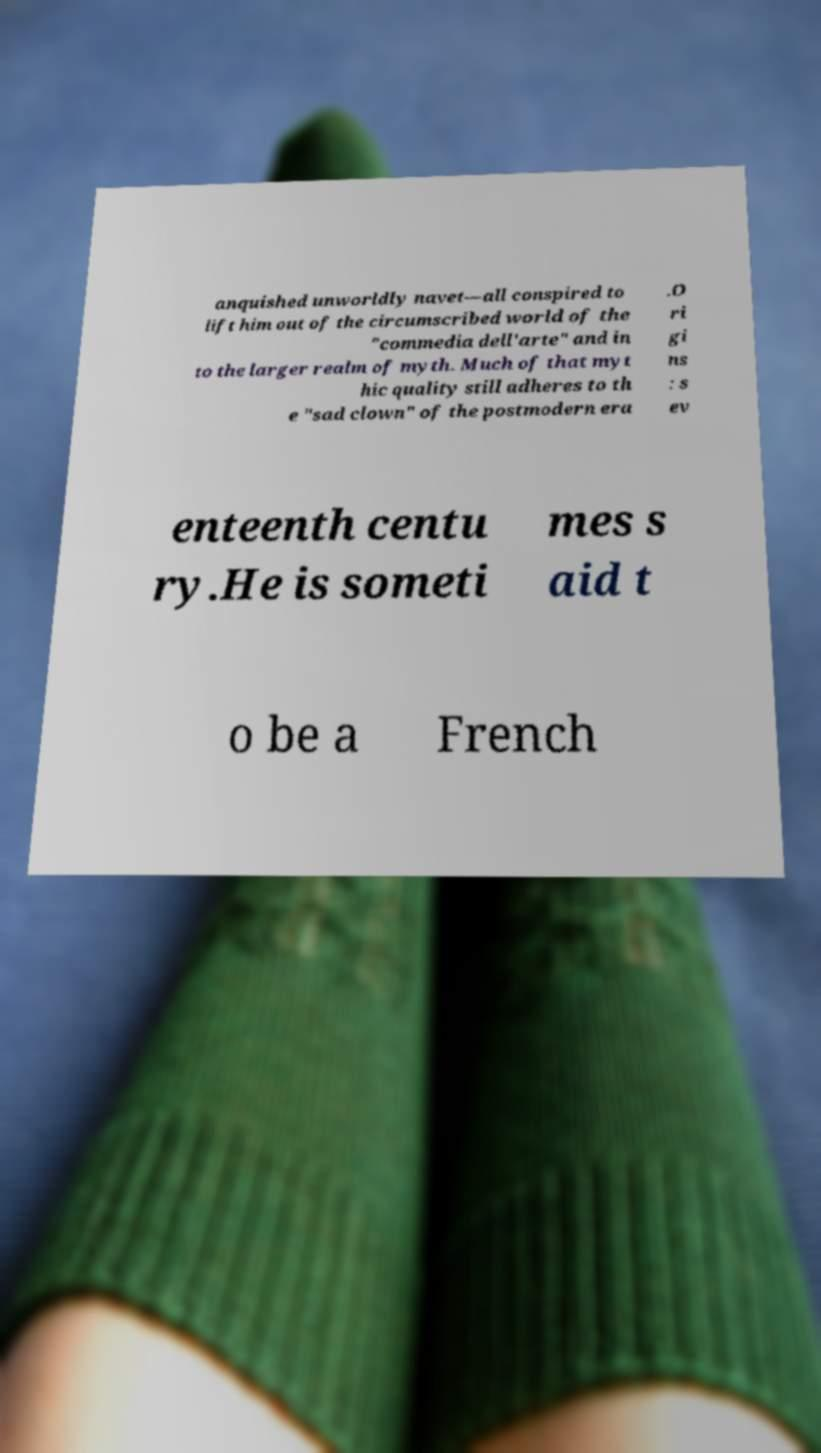What messages or text are displayed in this image? I need them in a readable, typed format. anquished unworldly navet—all conspired to lift him out of the circumscribed world of the "commedia dell'arte" and in to the larger realm of myth. Much of that myt hic quality still adheres to th e "sad clown" of the postmodern era .O ri gi ns : s ev enteenth centu ry.He is someti mes s aid t o be a French 